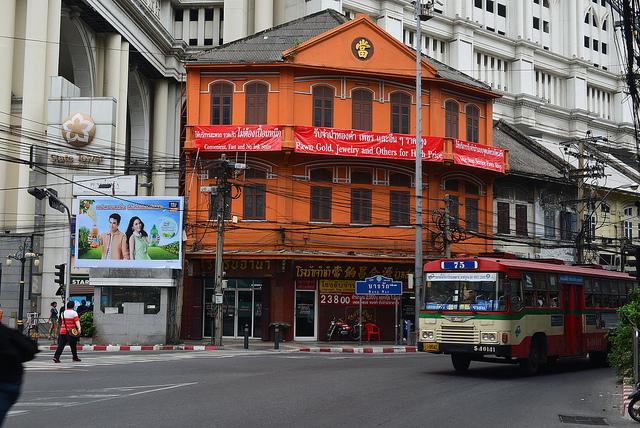What is the word on the nearest building to the right?
Be succinct. Mcdonald's. What is the name of the city this bus is touring?
Keep it brief. New york. What kind of vehicle is shown?
Answer briefly. Bus. What shape are the signs?
Write a very short answer. Rectangular. Where is the banner?
Be succinct. Building. Are any numbers visible in the picture?
Keep it brief. Yes. What color is building?
Answer briefly. Orange. Are people walking both ways?
Be succinct. No. Is this transportation used today?
Concise answer only. Yes. What kind of bus is this?
Be succinct. Public. What kind of building in the picture?
Keep it brief. Restaurant. How is the traffic on this street?
Concise answer only. Light. How many stories is the orange building?
Write a very short answer. 3. How many windows are open on the second floor?
Give a very brief answer. 0. Where are the power lines?
Quick response, please. Above street. 